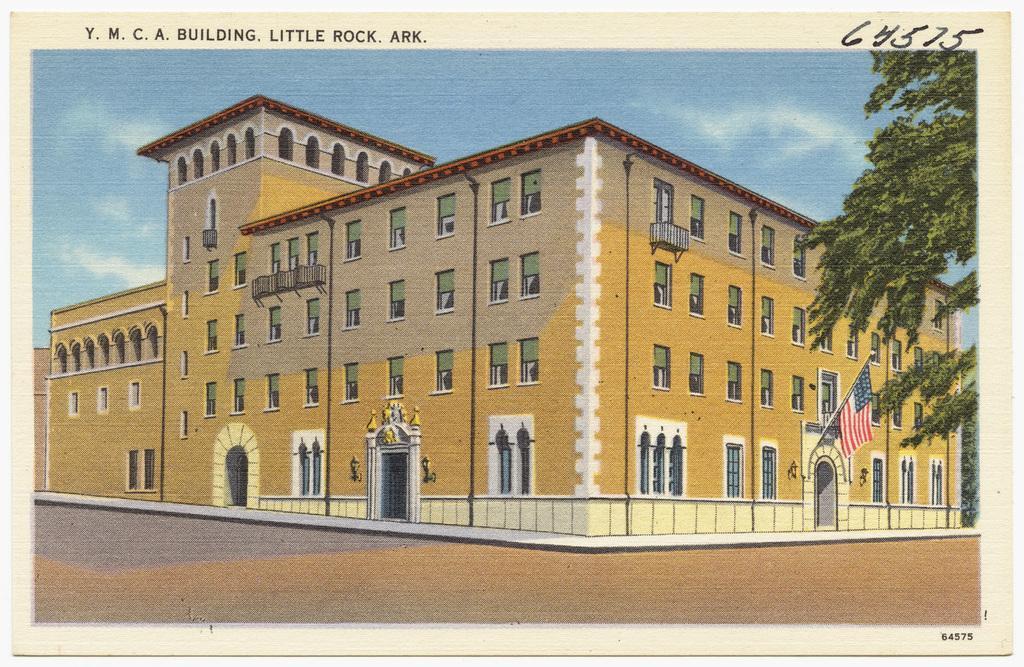Could you give a brief overview of what you see in this image? This image consists of a poster in which we can see a building along with windows and doors. On the right, we can see a flag. At the top, there is sky. On the right, there is a tree. At the bottom, there is ground. 